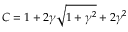Convert formula to latex. <formula><loc_0><loc_0><loc_500><loc_500>C = 1 + 2 \gamma \sqrt { 1 + \gamma ^ { 2 } } + 2 \gamma ^ { 2 }</formula> 